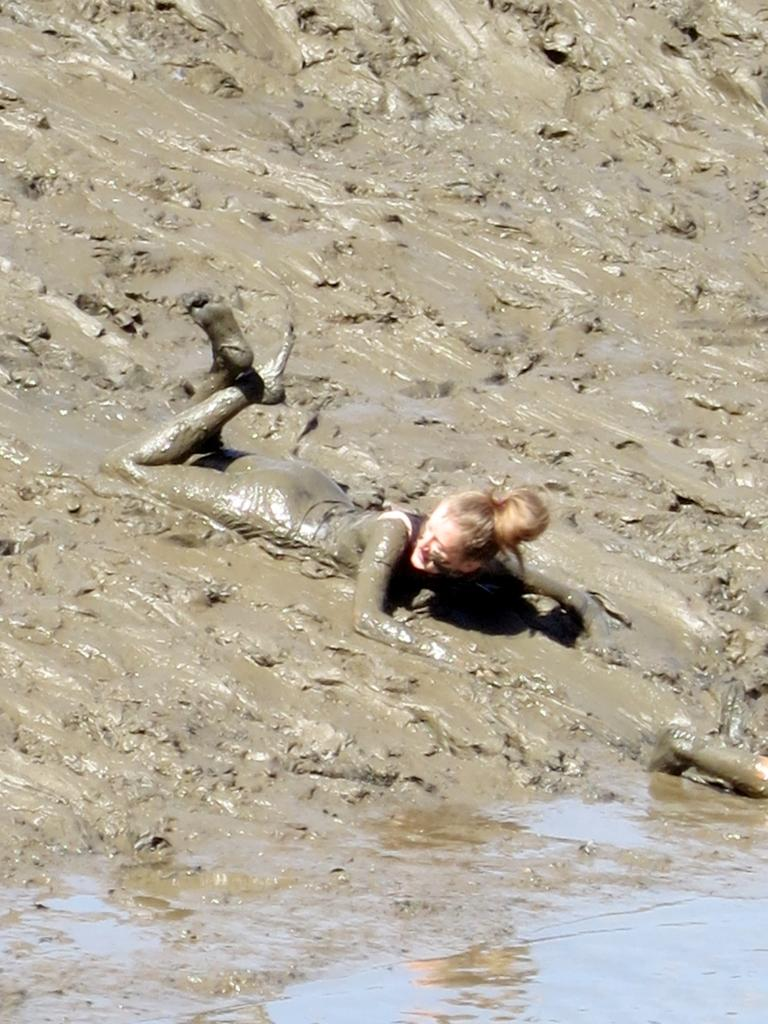Who or what can be seen in the image? There is a person visible in the image. What is the person standing on? The person is on mud. What type of zephyr is present in the image? There is no zephyr present in the image. A zephyr is a gentle breeze, and there is no mention of wind or weather in the provided facts. 